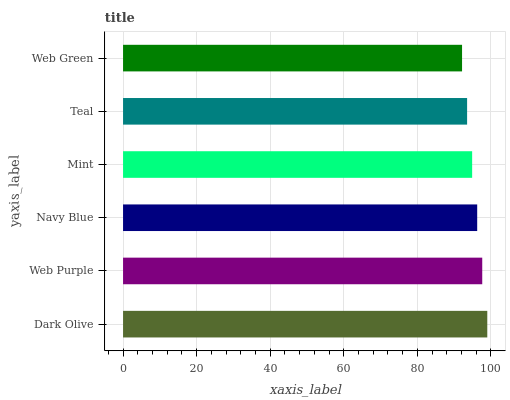Is Web Green the minimum?
Answer yes or no. Yes. Is Dark Olive the maximum?
Answer yes or no. Yes. Is Web Purple the minimum?
Answer yes or no. No. Is Web Purple the maximum?
Answer yes or no. No. Is Dark Olive greater than Web Purple?
Answer yes or no. Yes. Is Web Purple less than Dark Olive?
Answer yes or no. Yes. Is Web Purple greater than Dark Olive?
Answer yes or no. No. Is Dark Olive less than Web Purple?
Answer yes or no. No. Is Navy Blue the high median?
Answer yes or no. Yes. Is Mint the low median?
Answer yes or no. Yes. Is Mint the high median?
Answer yes or no. No. Is Web Purple the low median?
Answer yes or no. No. 